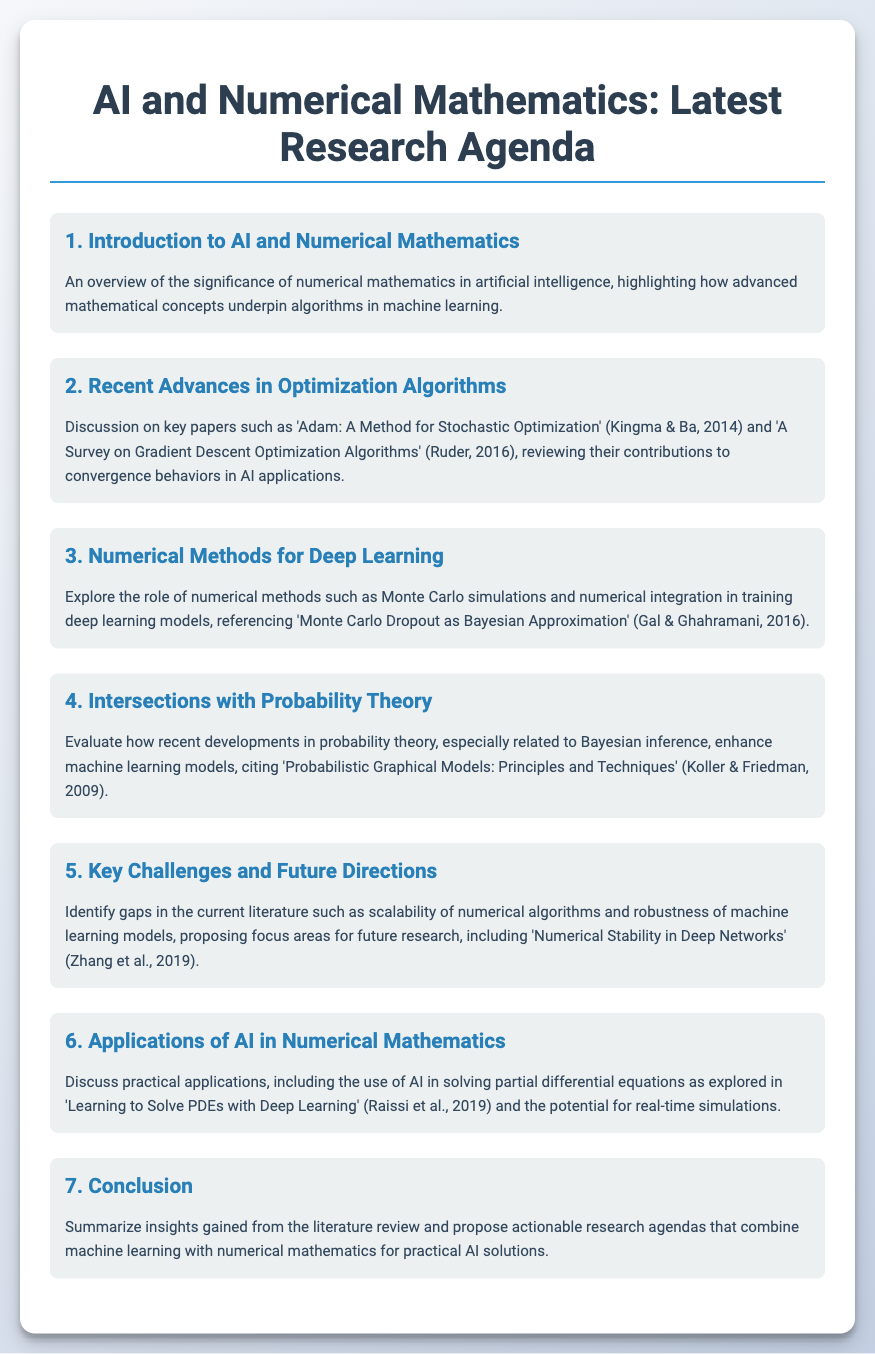what is the title of the agenda? The title of the agenda is presented at the beginning of the document, summarizing the focus of the review.
Answer: AI and Numerical Mathematics: Latest Research Agenda how many main items are discussed in the agenda? The number of main items is counted within the document's structure, specifically the numbered sections.
Answer: seven who are the authors of the paper 'Adam: A Method for Stochastic Optimization'? The authors of this significant paper on optimization algorithms are mentioned in the document, highlighting their contributions.
Answer: Kingma & Ba which method is referenced for evaluating deep learning models? The document discusses a specific method related to Bayesian approximation in deep learning.
Answer: Monte Carlo Dropout what year was the paper 'Probabilistic Graphical Models: Principles and Techniques' published? The publication year of this key paper is referenced as part of the discussion on probability theory and machine learning.
Answer: 2009 what is a key challenge identified for future research? One of the challenges highlighted in the document pertains to the limitations faced by existing algorithms in machine learning.
Answer: Scalability of numerical algorithms name an application of AI discussed in the agenda. The agenda includes a practical application of AI related to solving mathematical problems, particularly a specific type of equation.
Answer: Partial differential equations 